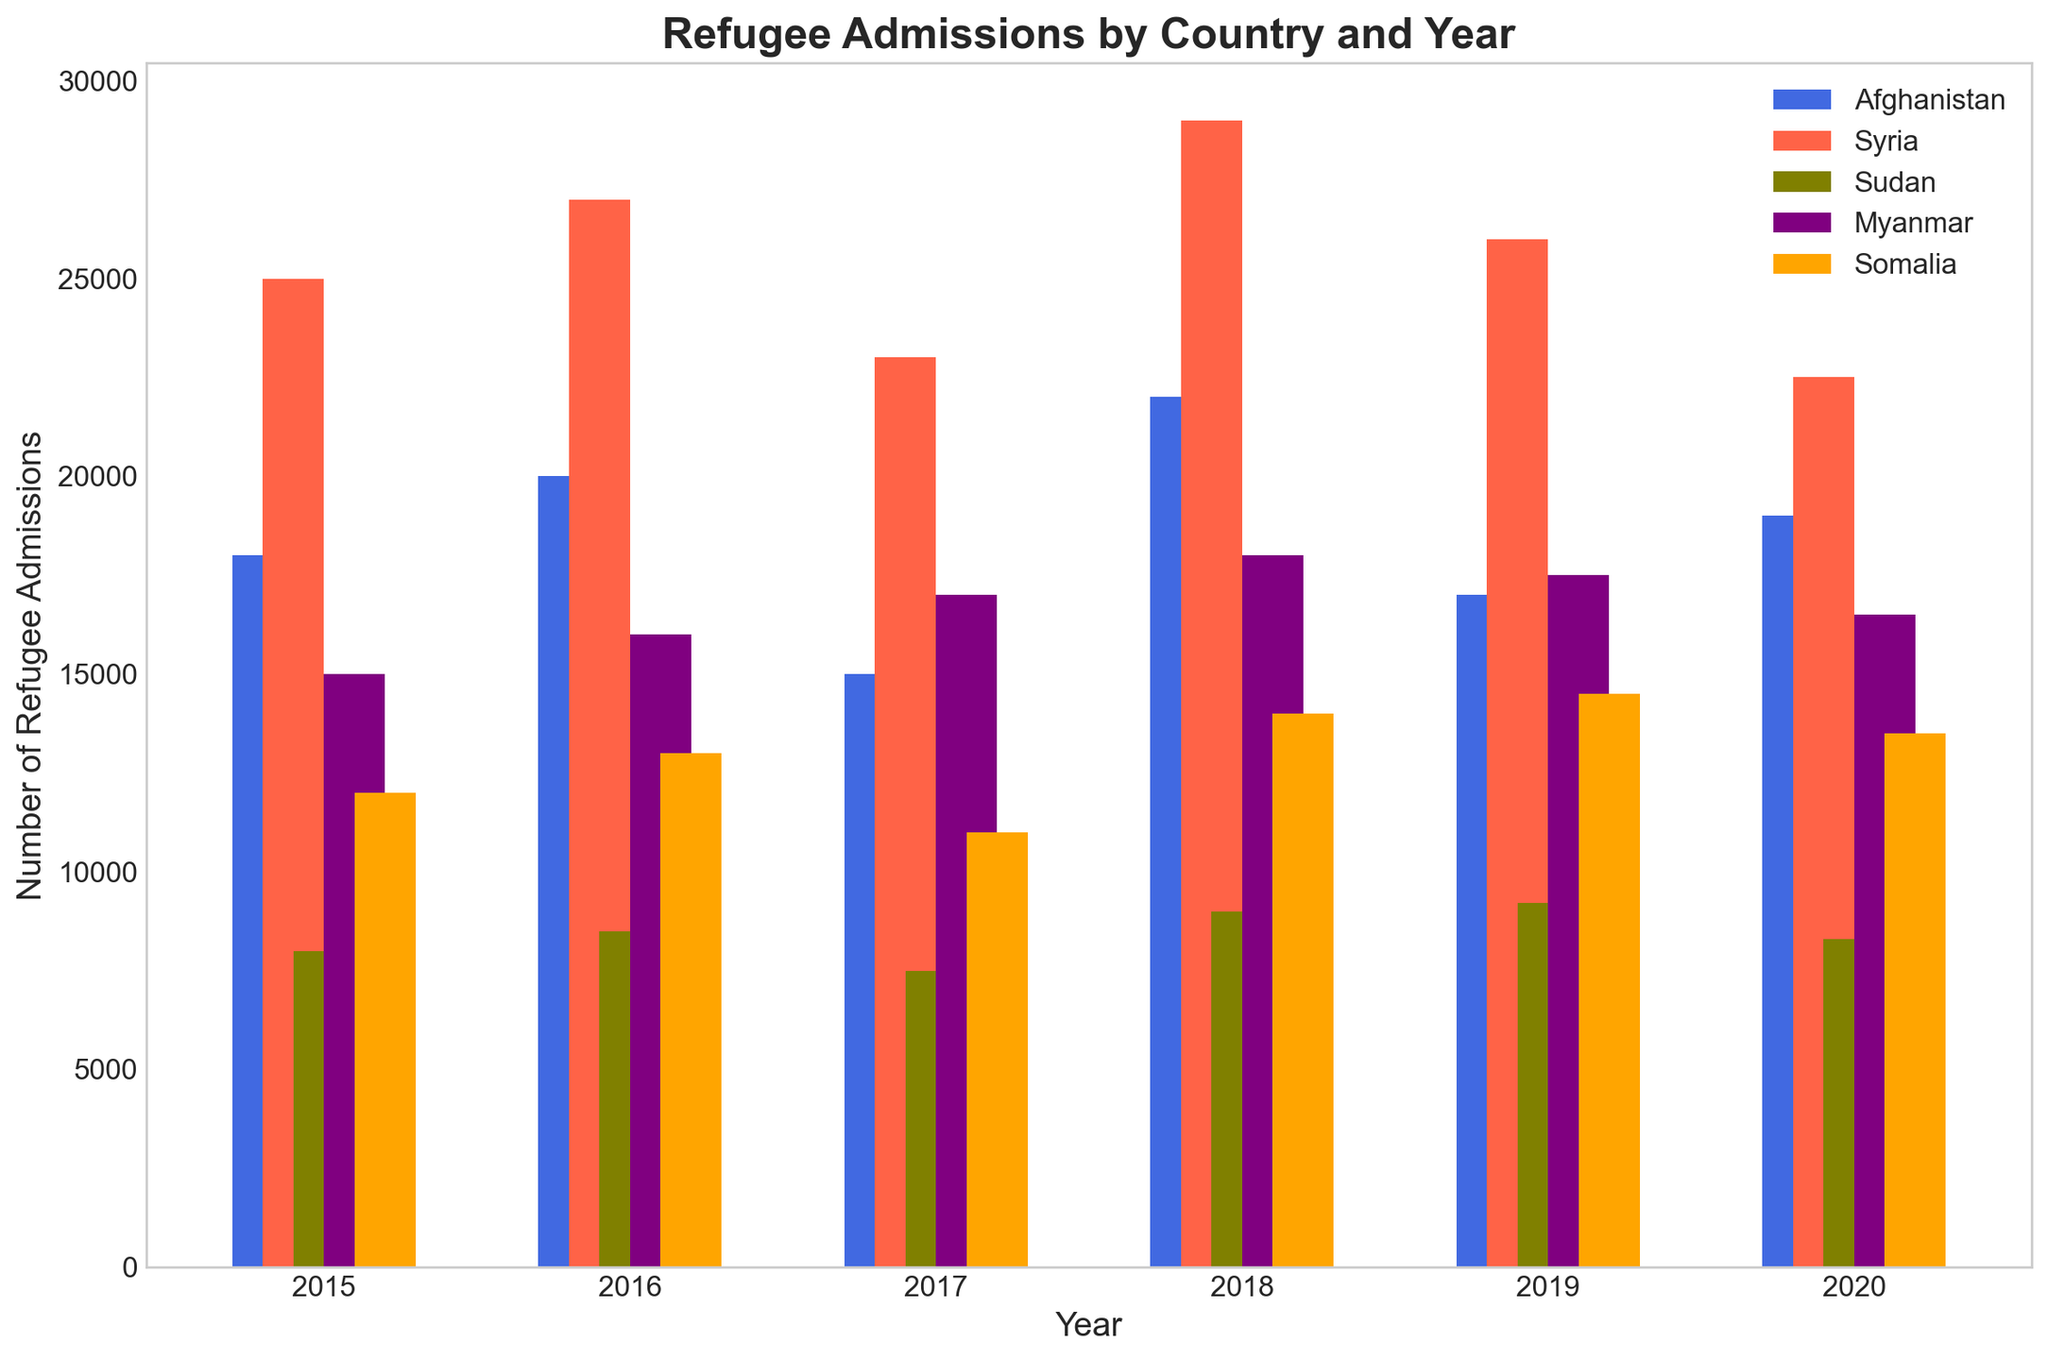What trend do you observe in refugee admissions from Afghanistan between 2015 and 2020? To observe the trend, we look at how the height of the bars changes for Afghanistan over the years. From the figure, we see an increase from 2015 to 2016, then a decrease from 2016 to 2017, followed by an increase until 2018, another decrease in 2019, and finally another increase in 2020.
Answer: Fluctuating pattern Which country had the highest number of refugee admissions in 2018? To find the country with the highest admissions, compare the height of the bars representing each country in the year 2018. Syria has the tallest bar in 2018.
Answer: Syria What is the total number of refugee admissions from Syria for the years 2015, 2016, and 2017? Add the heights of the bars for Syria for the years 2015, 2016, and 2017. The numbers are 25000 (2015) + 27000 (2016) + 23000 (2017). Summing them up: 25000 + 27000 + 23000 = 75000
Answer: 75000 How did refugee admissions from Sudan change from 2015 to 2020? Look at the height of the bars representing Sudan's refugee admissions from 2015 to 2020. The admissions rose slightly from 2015 to 2016, dropped in 2017, rose again in 2018 and 2019, and then dropped slightly in 2020.
Answer: Fluctuating with small overall increase Between which two consecutive years did Myanmar see the largest increase in refugee admissions? Compare the difference in height of the bars for Myanmar for each pair of consecutive years. The increase from 2015 to 2016 is 1000, from 2016 to 2017 is also 1000, 2017 to 2018 is also 1000, 2018 to 2019 sees a slight drop, and from 2019 to 2020 a drop again. The largest increase happens between each of the pairs 2015 to 2016, 2016 to 2017, and 2017 to 2018.
Answer: 2015-2016 or 2016-2017 or 2017-2018 What is the average number of refugee admissions from Somalia between 2015 and 2020? To find the average, sum up the refugee admissions for Somalia from 2015 to 2020 and divide by the number of years. The numbers are 12000, 13000, 11000, 14000, 14500, 13500. The total is 12000 + 13000 + 11000 + 14000 + 14500 + 13500 = 78000. The average is 78000 / 6 = 13000
Answer: 13000 Which country had the least fluctuations in refugee admissions from 2015 to 2020? To identify the country with the least fluctuations, look at the bars representing each country and observe the changes in their height over the years. Myanmar has the most stable, gradually increasing trend with very minimal fluctuations compared to other countries.
Answer: Myanmar 